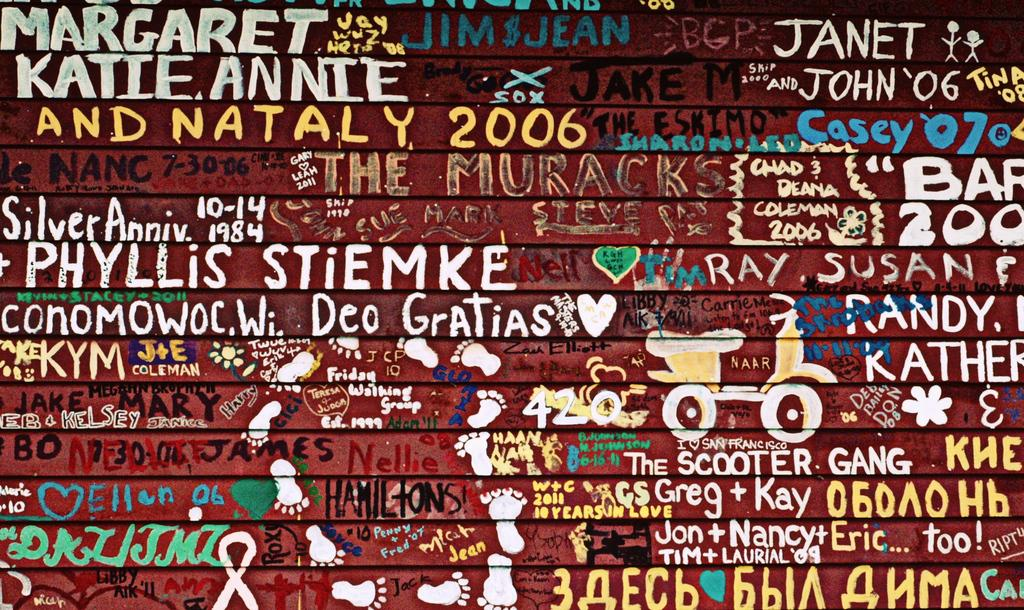<image>
Describe the image concisely. A fence with a bunch of writing and graffiti pictures on it, including many names. 